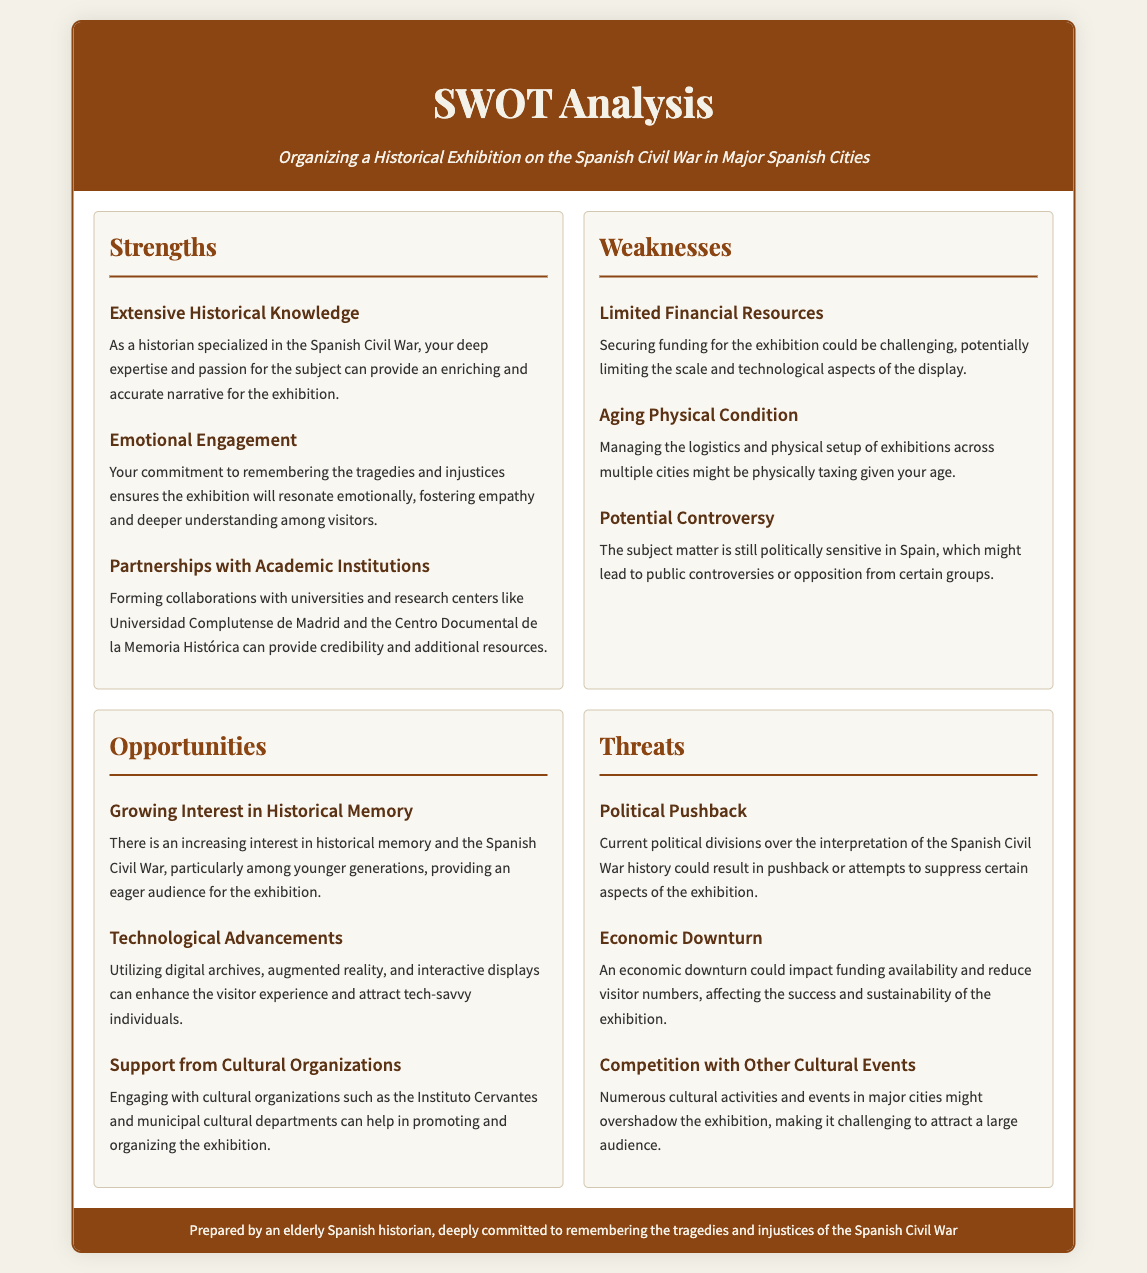what is the title of the document? The title of the document is clearly stated at the top as "SWOT Analysis".
Answer: SWOT Analysis how many strengths are listed in the analysis? The document lists a total of three strengths under the Strengths section.
Answer: 3 what is one potential controversy mentioned? The document points out that the subject matter of the Spanish Civil War can lead to potential controversies or opposition.
Answer: Potential controversy which cultural organization is mentioned as a potential supporter? The Instituto Cervantes is highlighted as an engaging cultural organization that can support the exhibition.
Answer: Instituto Cervantes what threat is associated with current political divisions? The document states that political pushback could result from current political divisions regarding the interpretation of the history.
Answer: Political pushback what opportunity relates to technological advancements? The document suggests that utilizing digital archives and augmented reality represents an opportunity to enhance visitor experiences.
Answer: Technological advancements how many weaknesses are identified in the analysis? The analysis identifies three weaknesses listed under the Weaknesses section.
Answer: 3 which major Spanish cities are targeted for the exhibition? The document does not specify which cities will host the exhibition, focusing instead on major cities as a general term.
Answer: Major Spanish Cities 